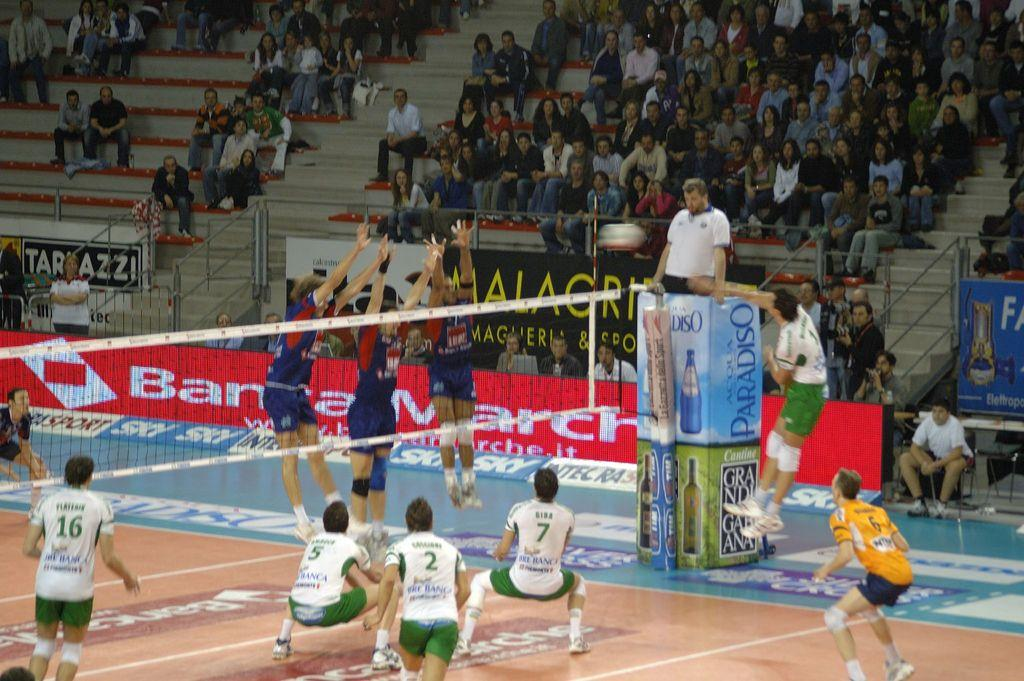<image>
Present a compact description of the photo's key features. The referee is up on a stand advertising Acqua Paradiso. 